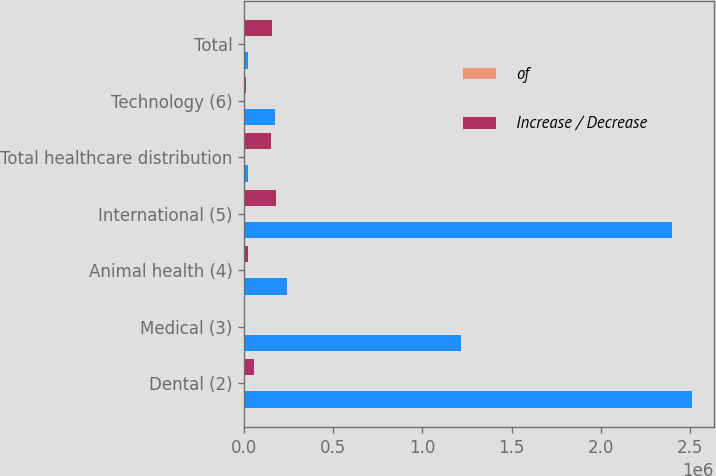Convert chart. <chart><loc_0><loc_0><loc_500><loc_500><stacked_bar_chart><ecel><fcel>Dental (2)<fcel>Medical (3)<fcel>Animal health (4)<fcel>International (5)<fcel>Total healthcare distribution<fcel>Technology (6)<fcel>Total<nl><fcel>nan<fcel>2.50992e+06<fcel>1.21702e+06<fcel>240082<fcel>2.3981e+06<fcel>21989<fcel>173208<fcel>21989<nl><fcel>of<fcel>38.4<fcel>18.6<fcel>3.7<fcel>36.7<fcel>97.4<fcel>2.6<fcel>100<nl><fcel>Increase / Decrease<fcel>57143<fcel>6145<fcel>21989<fcel>177013<fcel>148004<fcel>9919<fcel>157923<nl></chart> 